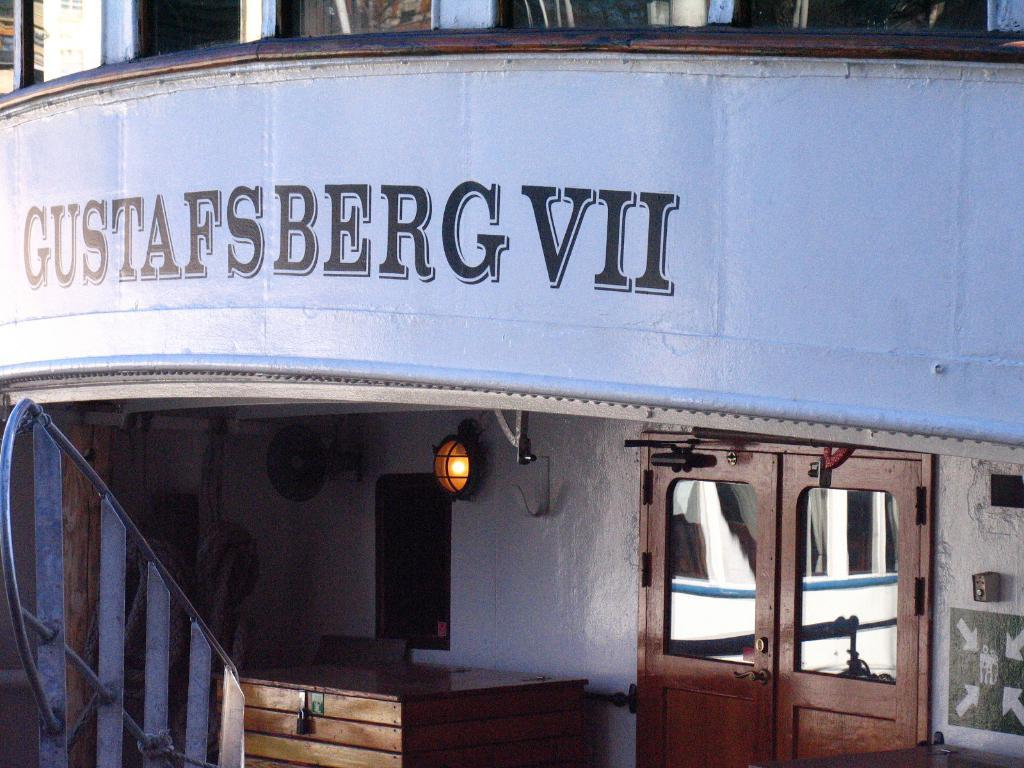What is the main subject of the image? The image depicts a building. What can be seen on the wall of the building? There is text on the wall of the building. What safety feature is present in the image? There are railings in the image. What source of illumination is visible in the image? A light is visible in the image. What type of container is present in the image? There is a wooden box in the image. How can people enter or exit the building? There are doors in the image. What type of cabbage is growing on the roof of the building in the image? There is no cabbage present on the roof of the building in the image. What advice does the grandfather give to the person in the image? There is no grandfather or person present in the image, so no advice can be given. 